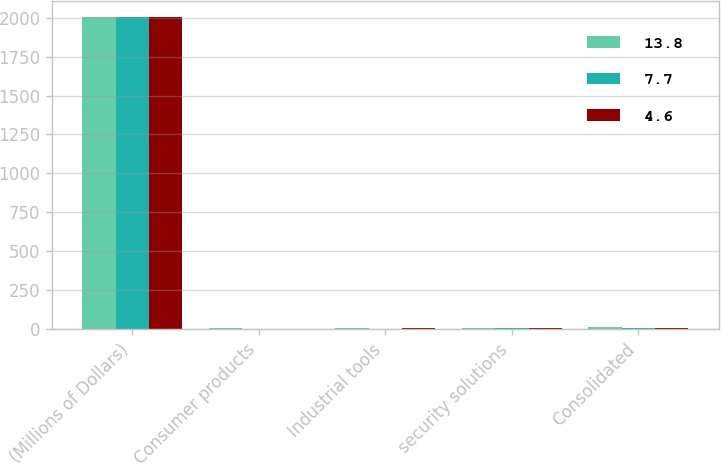<chart> <loc_0><loc_0><loc_500><loc_500><stacked_bar_chart><ecel><fcel>(Millions of Dollars)<fcel>Consumer products<fcel>Industrial tools<fcel>security solutions<fcel>Consolidated<nl><fcel>13.8<fcel>2006<fcel>3.2<fcel>5<fcel>5.6<fcel>13.8<nl><fcel>7.7<fcel>2005<fcel>0.5<fcel>1<fcel>3.1<fcel>4.6<nl><fcel>4.6<fcel>2004<fcel>1.3<fcel>2.9<fcel>3.5<fcel>7.7<nl></chart> 